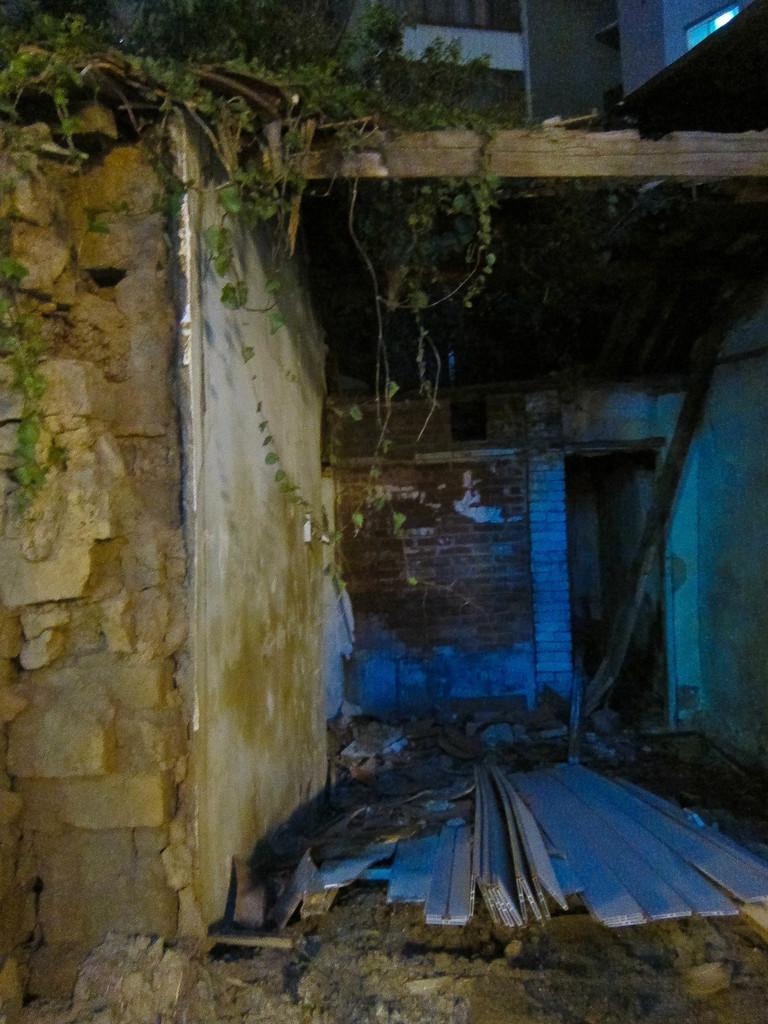Describe this image in one or two sentences. In this image there is a broken building. On it there are plants. 